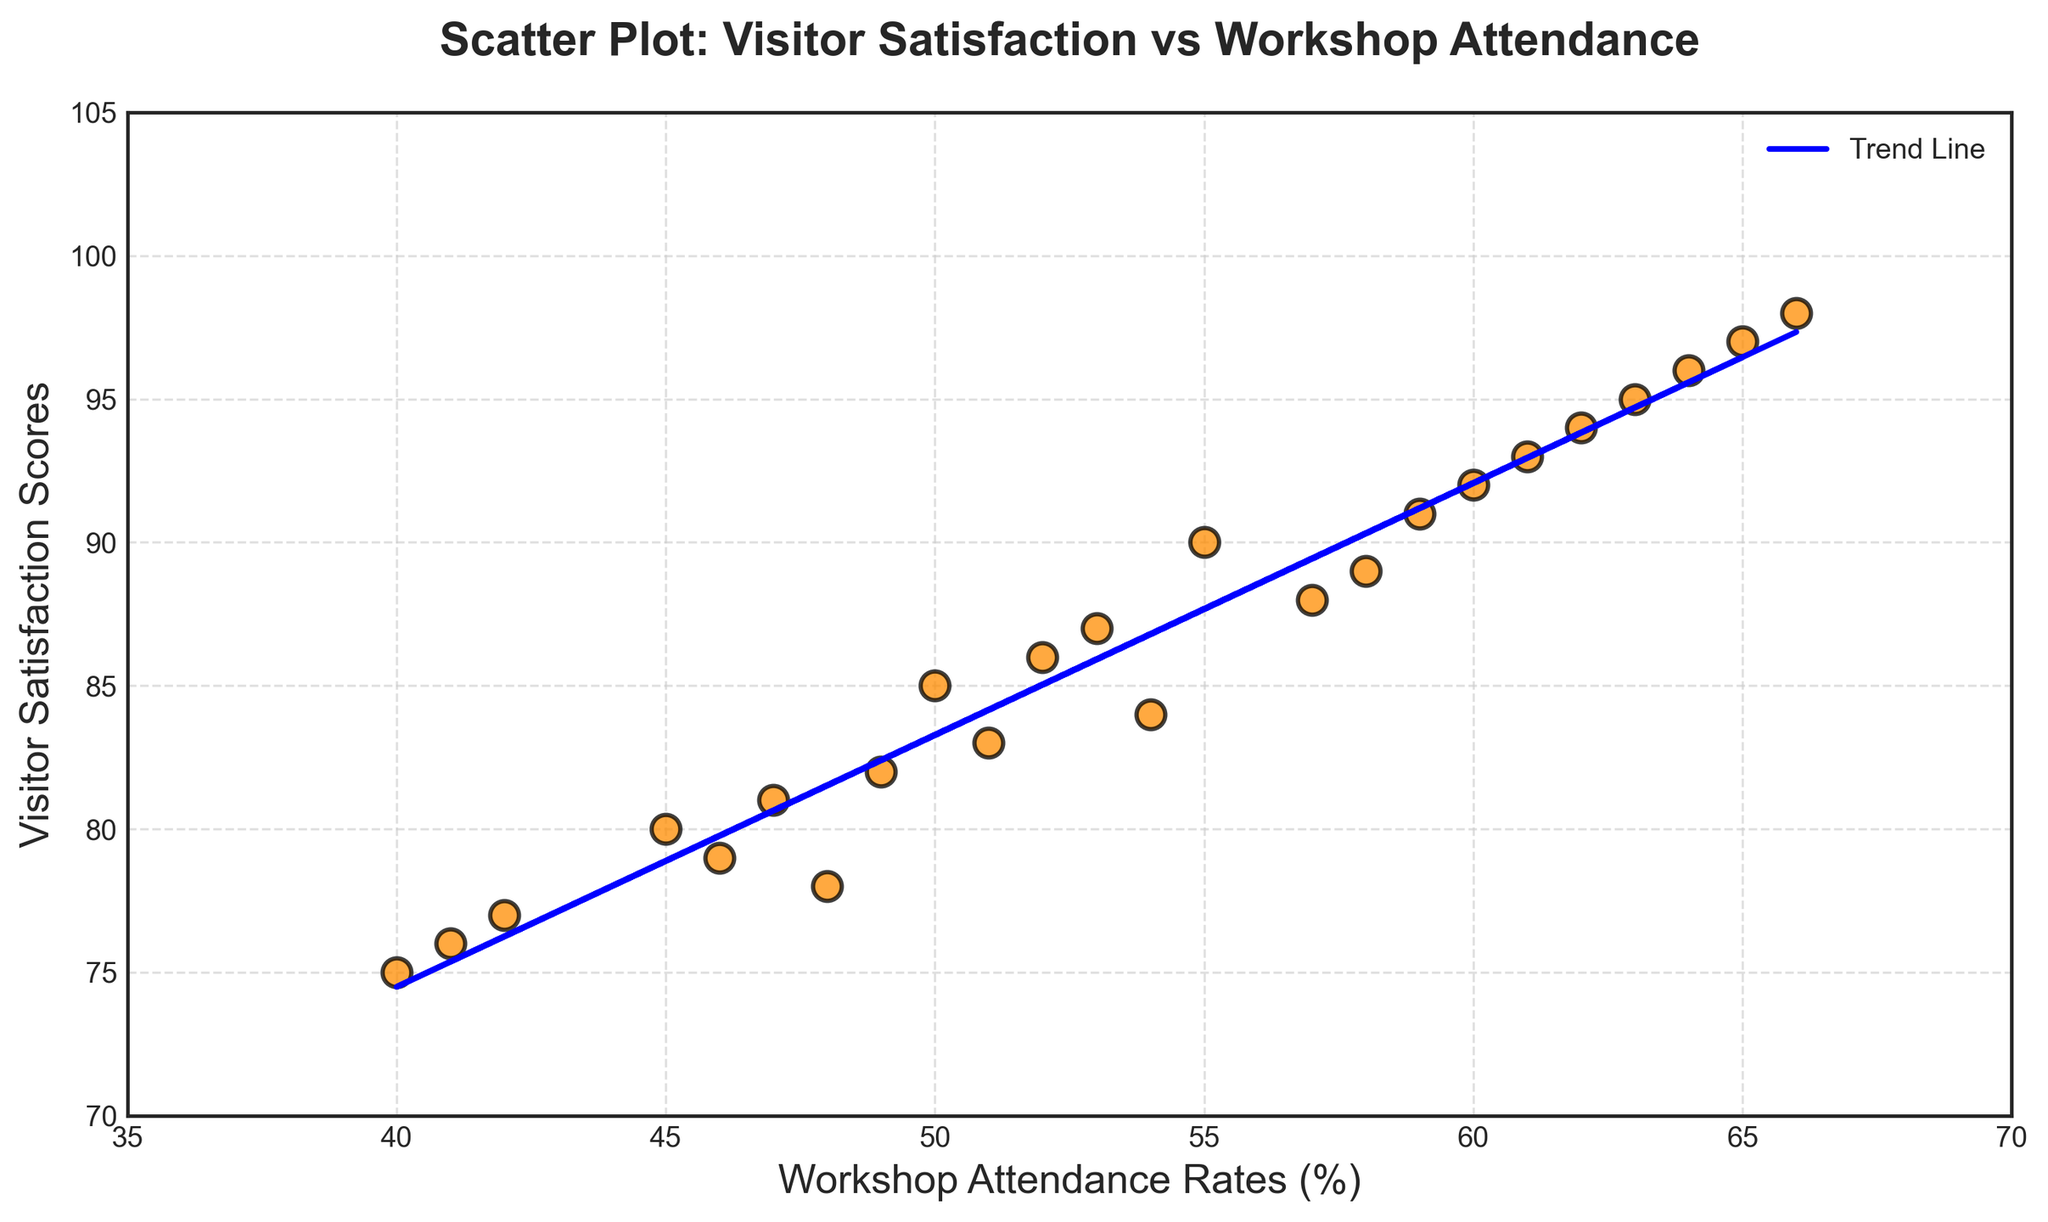What does the trend line in the scatter plot indicate about the relationship between Workshop Attendance and Visitor Satisfaction? The trend line represents the overall direction and strength of the relationship between Workshop Attendance and Visitor Satisfaction. In this plot, the trend line slopes upwards, indicating a positive correlation: as workshop attendance rates increase, visitor satisfaction scores also tend to increase.
Answer: Positive correlation What is the average Visitor Satisfaction score for all data points? To find the average Visitor Satisfaction score, sum up all the satisfaction scores and then divide by the number of data points. The sum of Visitor Satisfaction scores is: 85 + 90 + 78 + 92 + 80 + 87 + 94 + 88 + 75 + 93 + 77 + 89 + 83 + 95 + 82 + 91 + 79 + 86 + 81 + 96 + 84 + 97 + 76 + 98 = 1971. The number of data points is 24. So, the average is 1971 / 24 ≈ 82.13.
Answer: 82.13 What is the highest Visitor Satisfaction score, and what is its corresponding Workshop Attendance rate? The highest Visitor Satisfaction score in the plot is 98. Its corresponding Workshop Attendance rate is 66.
Answer: 98, 66 Which data point has the lowest Workshop Attendance rate and what is the Visitor Satisfaction score for that point? The data point with the lowest Workshop Attendance rate is 40. Its corresponding Visitor Satisfaction score is 75.
Answer: 40, 75 Compare the Visitor Satisfaction scores for Workshop Attendance rates of 45 and 60. Which one is higher? The Visitor Satisfaction score for a Workshop Attendance rate of 45 is 80. For a Workshop Attendance rate of 60, it is 92. Hence, the score for the attendance rate of 60 is higher.
Answer: 60 is higher How many data points are there where the Visitor Satisfaction score is greater than 90? By visually inspecting the scatter plot, count the data points above the 90 score level. There are 9 data points with a Visitor Satisfaction score greater than 90.
Answer: 9 What is the difference between the highest and the lowest Visitor Satisfaction scores? The highest Visitor Satisfaction score is 98, and the lowest is 75. The difference between them is 98 - 75 = 23.
Answer: 23 Describe the visual characteristics of the scatter plot markers (e.g., shape, color). The markers in the scatter plot are circular (shape) and are colored dark orange with black edges and white centers. They have a size of 100 and an alpha transparency level of 0.75.
Answer: Dark orange circles with black edges 